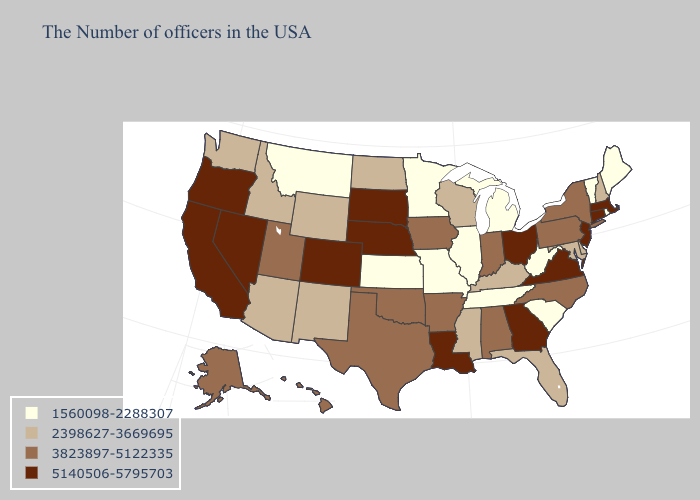Name the states that have a value in the range 2398627-3669695?
Be succinct. New Hampshire, Delaware, Maryland, Florida, Kentucky, Wisconsin, Mississippi, North Dakota, Wyoming, New Mexico, Arizona, Idaho, Washington. Name the states that have a value in the range 3823897-5122335?
Write a very short answer. New York, Pennsylvania, North Carolina, Indiana, Alabama, Arkansas, Iowa, Oklahoma, Texas, Utah, Alaska, Hawaii. Name the states that have a value in the range 3823897-5122335?
Keep it brief. New York, Pennsylvania, North Carolina, Indiana, Alabama, Arkansas, Iowa, Oklahoma, Texas, Utah, Alaska, Hawaii. Is the legend a continuous bar?
Quick response, please. No. Among the states that border Nebraska , which have the lowest value?
Concise answer only. Missouri, Kansas. How many symbols are there in the legend?
Concise answer only. 4. Name the states that have a value in the range 5140506-5795703?
Be succinct. Massachusetts, Connecticut, New Jersey, Virginia, Ohio, Georgia, Louisiana, Nebraska, South Dakota, Colorado, Nevada, California, Oregon. Does Delaware have the lowest value in the USA?
Concise answer only. No. How many symbols are there in the legend?
Quick response, please. 4. How many symbols are there in the legend?
Concise answer only. 4. Does the map have missing data?
Be succinct. No. Name the states that have a value in the range 1560098-2288307?
Concise answer only. Maine, Rhode Island, Vermont, South Carolina, West Virginia, Michigan, Tennessee, Illinois, Missouri, Minnesota, Kansas, Montana. What is the value of New York?
Be succinct. 3823897-5122335. Does Hawaii have a lower value than Rhode Island?
Be succinct. No. Which states have the lowest value in the South?
Write a very short answer. South Carolina, West Virginia, Tennessee. 